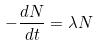Convert formula to latex. <formula><loc_0><loc_0><loc_500><loc_500>- \frac { d N } { d t } = \lambda N</formula> 